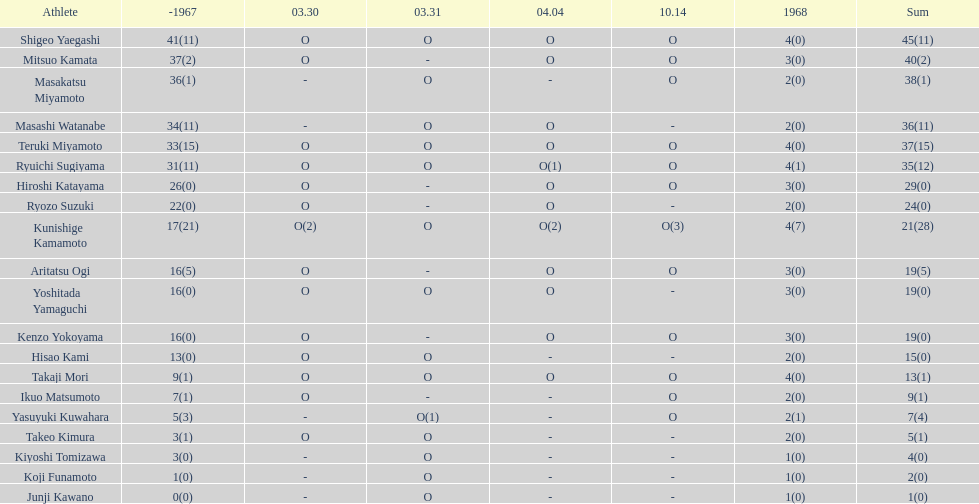How many more total appearances did shigeo yaegashi have than mitsuo kamata? 5. 